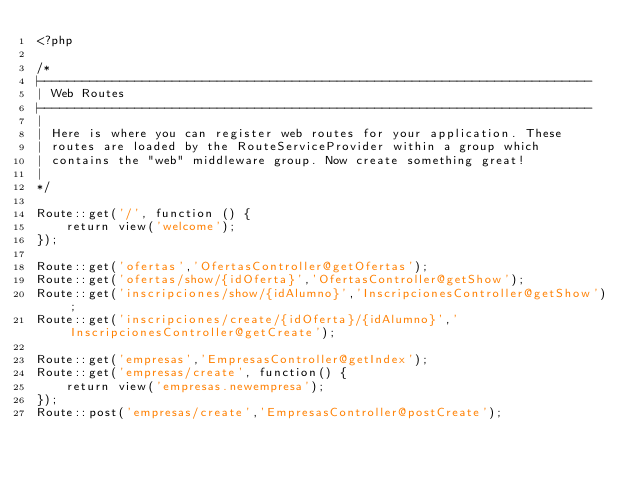Convert code to text. <code><loc_0><loc_0><loc_500><loc_500><_PHP_><?php

/*
|--------------------------------------------------------------------------
| Web Routes
|--------------------------------------------------------------------------
|
| Here is where you can register web routes for your application. These
| routes are loaded by the RouteServiceProvider within a group which
| contains the "web" middleware group. Now create something great!
|
*/

Route::get('/', function () {
    return view('welcome');
});

Route::get('ofertas','OfertasController@getOfertas');
Route::get('ofertas/show/{idOferta}','OfertasController@getShow');
Route::get('inscripciones/show/{idAlumno}','InscripcionesController@getShow');
Route::get('inscripciones/create/{idOferta}/{idAlumno}','InscripcionesController@getCreate');

Route::get('empresas','EmpresasController@getIndex');
Route::get('empresas/create', function() {
	return view('empresas.newempresa');
});
Route::post('empresas/create','EmpresasController@postCreate');

</code> 